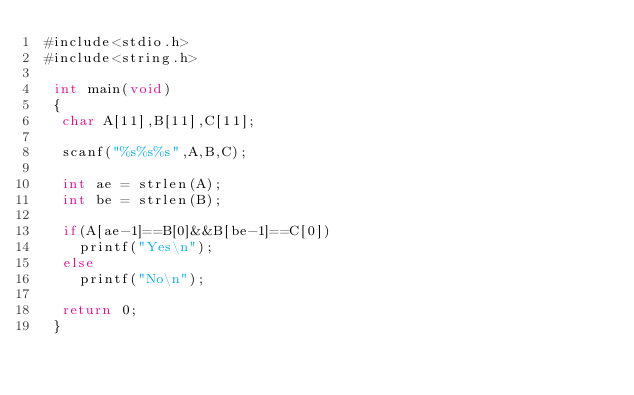Convert code to text. <code><loc_0><loc_0><loc_500><loc_500><_C++_> #include<stdio.h>
 #include<string.h>

  int main(void)
  {
   char A[11],B[11],C[11];

   scanf("%s%s%s",A,B,C);

   int ae = strlen(A);
   int be = strlen(B);

   if(A[ae-1]==B[0]&&B[be-1]==C[0])
     printf("Yes\n");
   else
     printf("No\n");

   return 0;
  }</code> 